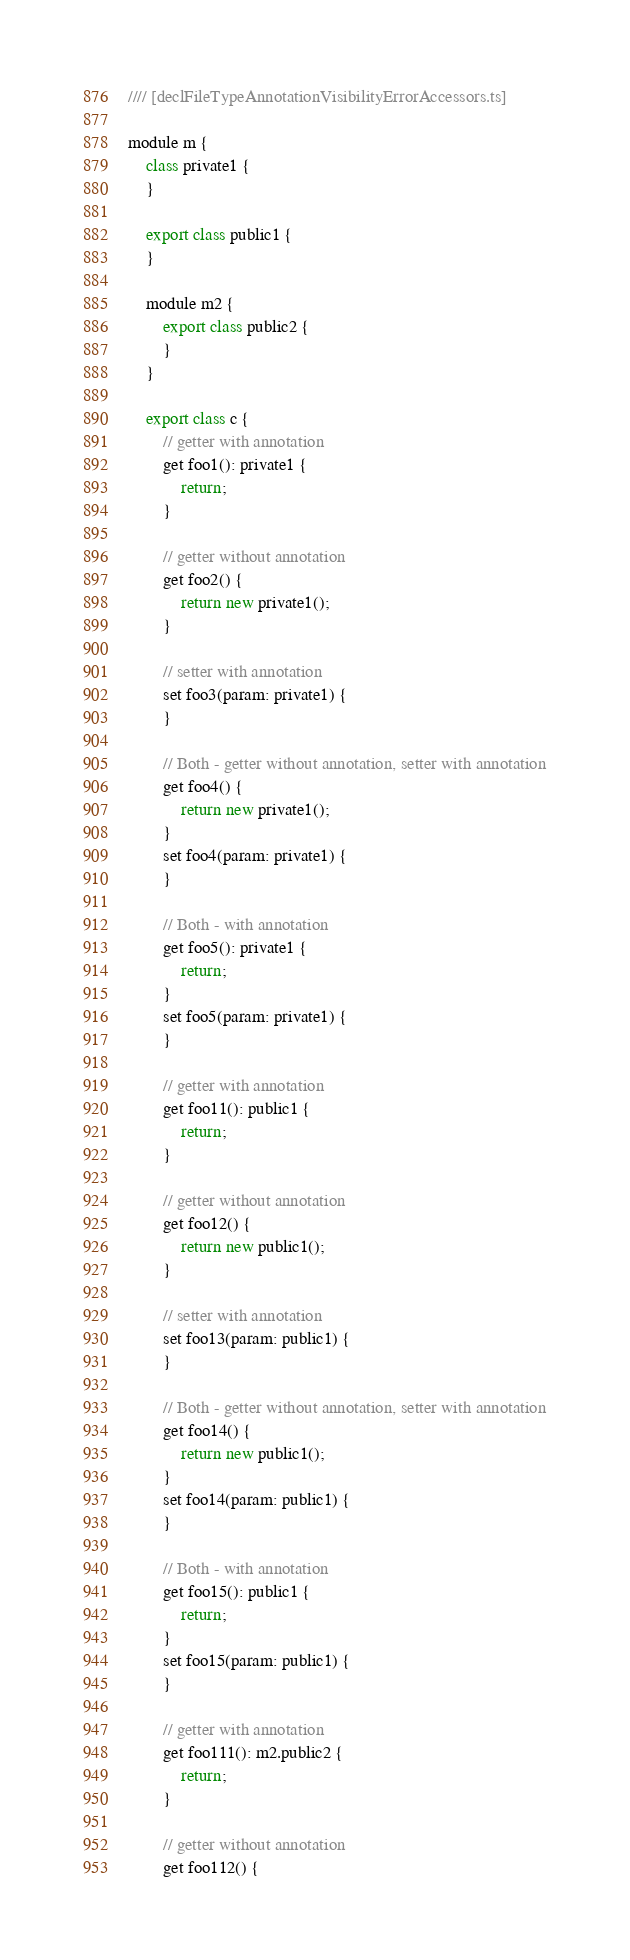<code> <loc_0><loc_0><loc_500><loc_500><_JavaScript_>//// [declFileTypeAnnotationVisibilityErrorAccessors.ts]

module m {
    class private1 {
    }

    export class public1 {
    }

    module m2 {
        export class public2 {
        }
    }
    
    export class c {
        // getter with annotation
        get foo1(): private1 {
            return;
        }

        // getter without annotation
        get foo2() {
            return new private1();
        }

        // setter with annotation
        set foo3(param: private1) {
        }

        // Both - getter without annotation, setter with annotation
        get foo4() {
            return new private1();
        }
        set foo4(param: private1) {
        }

        // Both - with annotation
        get foo5(): private1 {
            return;
        }
        set foo5(param: private1) {
        }
    
        // getter with annotation
        get foo11(): public1 {
            return;
        }

        // getter without annotation
        get foo12() {
            return new public1();
        }

        // setter with annotation
        set foo13(param: public1) {
        }

        // Both - getter without annotation, setter with annotation
        get foo14() {
            return new public1();
        }
        set foo14(param: public1) {
        }

        // Both - with annotation
        get foo15(): public1 {
            return;
        }
        set foo15(param: public1) {
        }

        // getter with annotation
        get foo111(): m2.public2 {
            return;
        }

        // getter without annotation
        get foo112() {</code> 